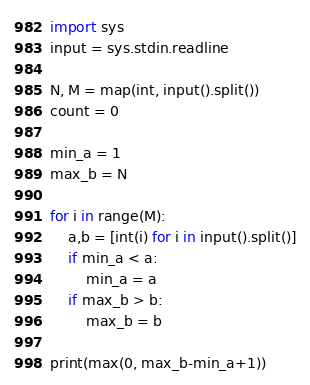Convert code to text. <code><loc_0><loc_0><loc_500><loc_500><_Python_>import sys
input = sys.stdin.readline

N, M = map(int, input().split())
count = 0

min_a = 1
max_b = N

for i in range(M):
    a,b = [int(i) for i in input().split()]
    if min_a < a:
        min_a = a
    if max_b > b:
        max_b = b

print(max(0, max_b-min_a+1))
</code> 